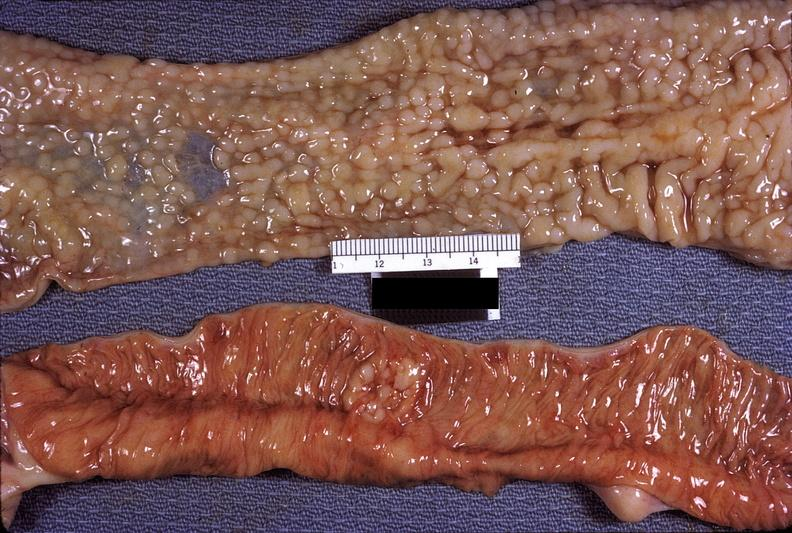s infant body present?
Answer the question using a single word or phrase. No 